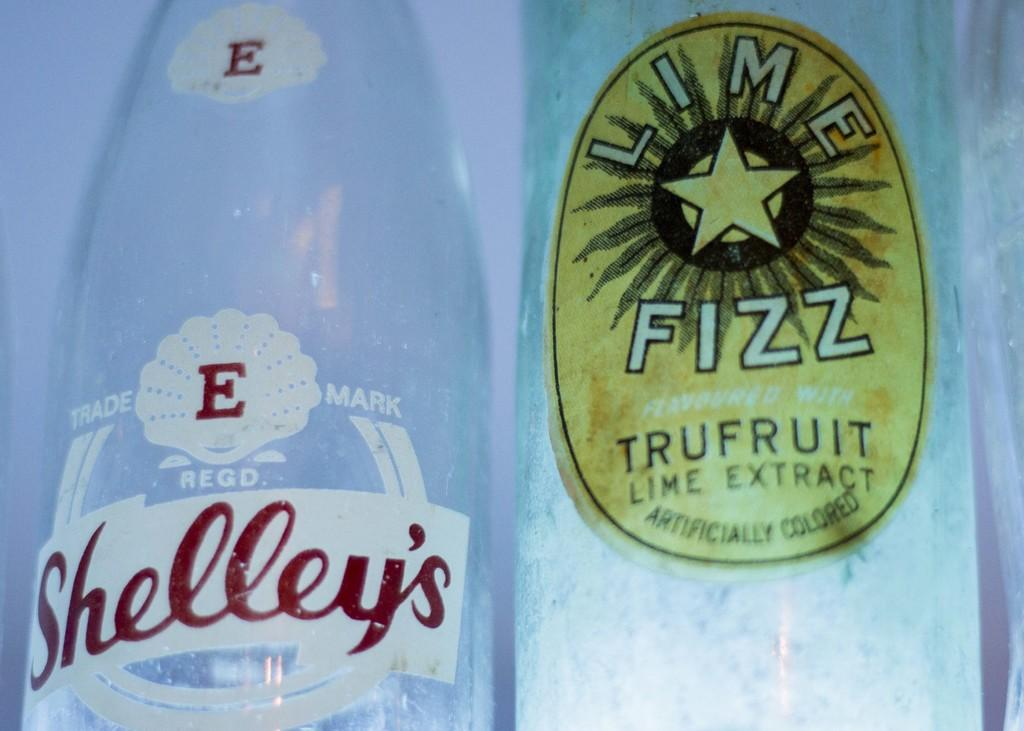How many bottles are visible in the image? There are 2 bottles in the image. What is on top of the bottles? There are stickers on top of the bottles. What type of vegetable is being insured in the image? There is no vegetable or insurance-related information present in the image. 